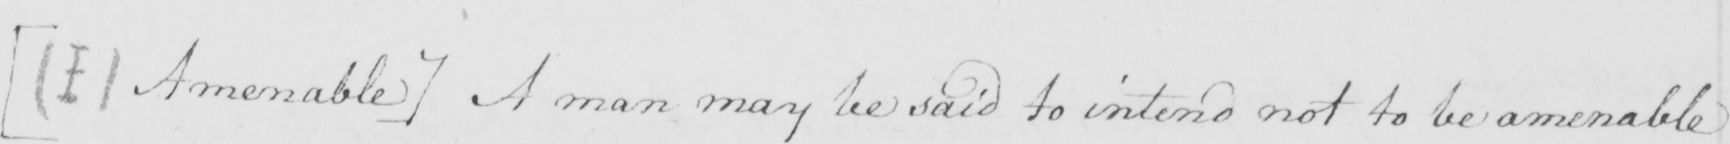Can you read and transcribe this handwriting? [  ( I )  Amenable ]  A man may be said to intend not to be amenable 